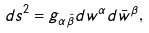<formula> <loc_0><loc_0><loc_500><loc_500>d s ^ { 2 } = g _ { \alpha \bar { \beta } } d w ^ { \alpha } d \bar { w } ^ { \beta } ,</formula> 